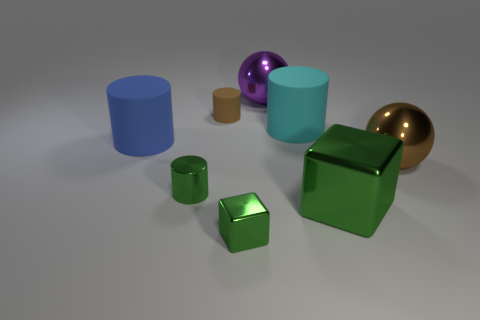How many tiny cylinders are the same color as the large cube?
Make the answer very short. 1. Are there any objects that are to the left of the rubber cylinder left of the green cylinder?
Keep it short and to the point. No. Is the color of the sphere that is in front of the blue rubber thing the same as the tiny thing on the left side of the tiny rubber cylinder?
Your answer should be very brief. No. There is a shiny cube that is the same size as the brown metal object; what is its color?
Make the answer very short. Green. Are there the same number of small matte objects behind the big purple metallic object and tiny metallic blocks that are left of the tiny metallic cube?
Give a very brief answer. Yes. What is the material of the big cylinder that is to the left of the big matte object that is behind the big blue cylinder?
Provide a short and direct response. Rubber. What number of objects are either large purple spheres or large metal cubes?
Provide a succinct answer. 2. There is a shiny cylinder that is the same color as the tiny metallic block; what is its size?
Provide a short and direct response. Small. Is the number of purple spheres less than the number of shiny balls?
Make the answer very short. Yes. The blue thing that is made of the same material as the tiny brown cylinder is what size?
Ensure brevity in your answer.  Large. 